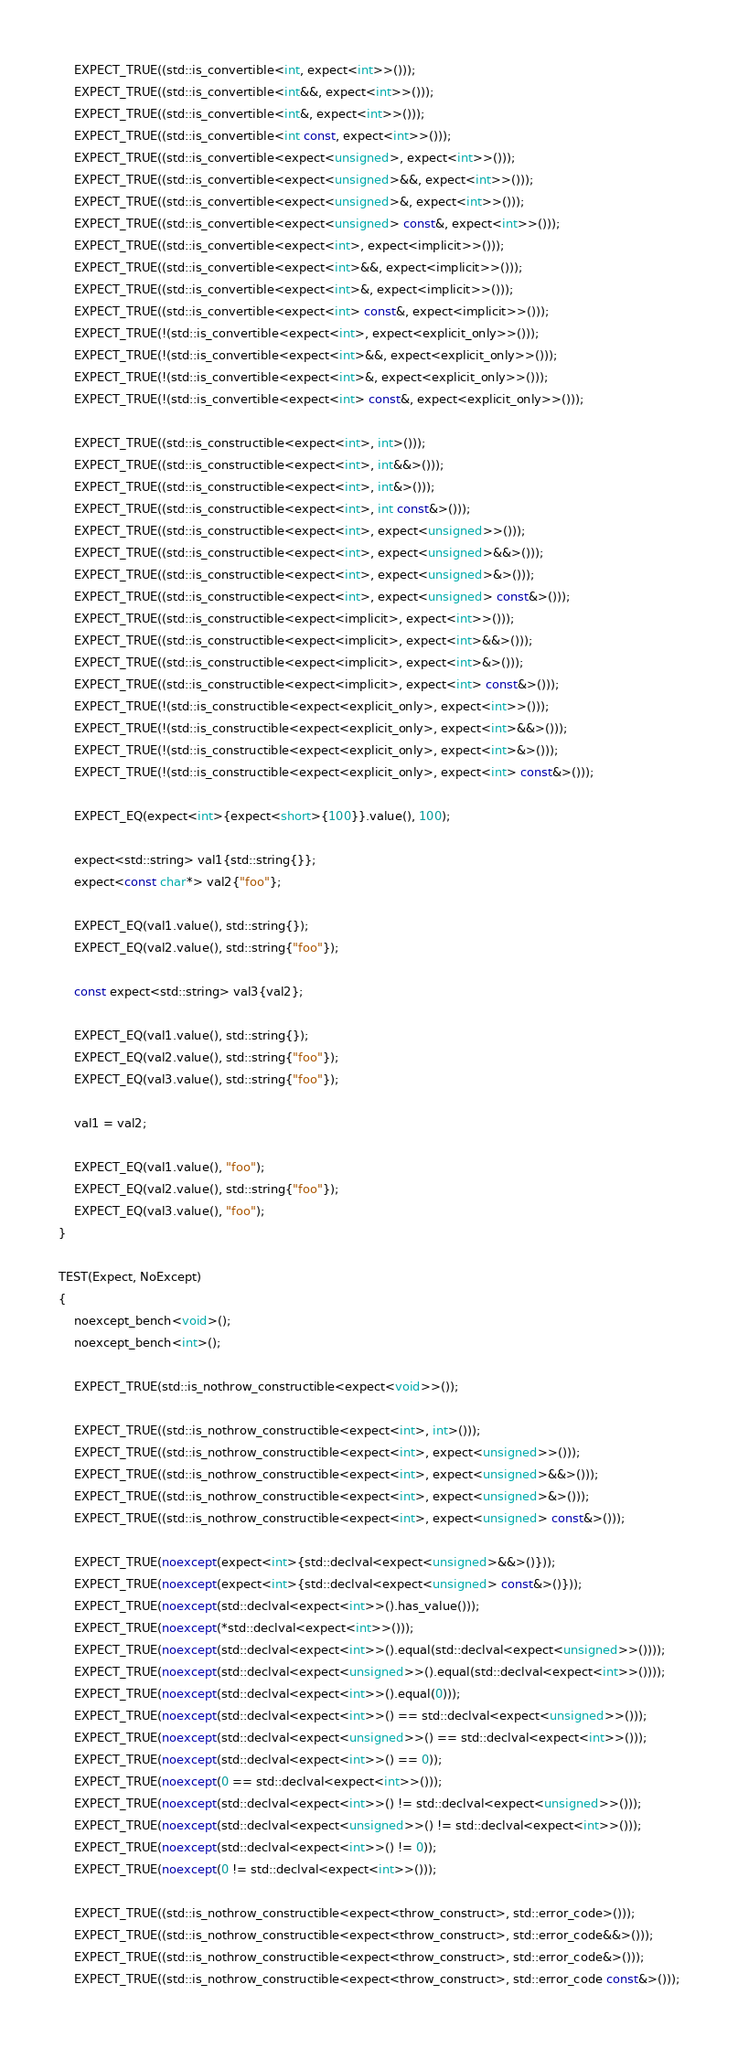Convert code to text. <code><loc_0><loc_0><loc_500><loc_500><_C++_>
    EXPECT_TRUE((std::is_convertible<int, expect<int>>()));
    EXPECT_TRUE((std::is_convertible<int&&, expect<int>>()));
    EXPECT_TRUE((std::is_convertible<int&, expect<int>>()));
    EXPECT_TRUE((std::is_convertible<int const, expect<int>>()));
    EXPECT_TRUE((std::is_convertible<expect<unsigned>, expect<int>>()));
    EXPECT_TRUE((std::is_convertible<expect<unsigned>&&, expect<int>>()));
    EXPECT_TRUE((std::is_convertible<expect<unsigned>&, expect<int>>()));
    EXPECT_TRUE((std::is_convertible<expect<unsigned> const&, expect<int>>()));
    EXPECT_TRUE((std::is_convertible<expect<int>, expect<implicit>>()));
    EXPECT_TRUE((std::is_convertible<expect<int>&&, expect<implicit>>()));
    EXPECT_TRUE((std::is_convertible<expect<int>&, expect<implicit>>()));
    EXPECT_TRUE((std::is_convertible<expect<int> const&, expect<implicit>>()));
    EXPECT_TRUE(!(std::is_convertible<expect<int>, expect<explicit_only>>()));
    EXPECT_TRUE(!(std::is_convertible<expect<int>&&, expect<explicit_only>>()));
    EXPECT_TRUE(!(std::is_convertible<expect<int>&, expect<explicit_only>>()));
    EXPECT_TRUE(!(std::is_convertible<expect<int> const&, expect<explicit_only>>()));

    EXPECT_TRUE((std::is_constructible<expect<int>, int>()));
    EXPECT_TRUE((std::is_constructible<expect<int>, int&&>()));
    EXPECT_TRUE((std::is_constructible<expect<int>, int&>()));
    EXPECT_TRUE((std::is_constructible<expect<int>, int const&>()));
    EXPECT_TRUE((std::is_constructible<expect<int>, expect<unsigned>>()));
    EXPECT_TRUE((std::is_constructible<expect<int>, expect<unsigned>&&>()));
    EXPECT_TRUE((std::is_constructible<expect<int>, expect<unsigned>&>()));
    EXPECT_TRUE((std::is_constructible<expect<int>, expect<unsigned> const&>()));
    EXPECT_TRUE((std::is_constructible<expect<implicit>, expect<int>>()));
    EXPECT_TRUE((std::is_constructible<expect<implicit>, expect<int>&&>()));
    EXPECT_TRUE((std::is_constructible<expect<implicit>, expect<int>&>()));
    EXPECT_TRUE((std::is_constructible<expect<implicit>, expect<int> const&>()));
    EXPECT_TRUE(!(std::is_constructible<expect<explicit_only>, expect<int>>()));
    EXPECT_TRUE(!(std::is_constructible<expect<explicit_only>, expect<int>&&>()));
    EXPECT_TRUE(!(std::is_constructible<expect<explicit_only>, expect<int>&>()));
    EXPECT_TRUE(!(std::is_constructible<expect<explicit_only>, expect<int> const&>()));

    EXPECT_EQ(expect<int>{expect<short>{100}}.value(), 100);

    expect<std::string> val1{std::string{}};
    expect<const char*> val2{"foo"};

    EXPECT_EQ(val1.value(), std::string{});
    EXPECT_EQ(val2.value(), std::string{"foo"});

    const expect<std::string> val3{val2};

    EXPECT_EQ(val1.value(), std::string{});
    EXPECT_EQ(val2.value(), std::string{"foo"});
    EXPECT_EQ(val3.value(), std::string{"foo"});

    val1 = val2;

    EXPECT_EQ(val1.value(), "foo");
    EXPECT_EQ(val2.value(), std::string{"foo"});
    EXPECT_EQ(val3.value(), "foo");
}

TEST(Expect, NoExcept)
{
    noexcept_bench<void>();
    noexcept_bench<int>();

    EXPECT_TRUE(std::is_nothrow_constructible<expect<void>>());

    EXPECT_TRUE((std::is_nothrow_constructible<expect<int>, int>()));
    EXPECT_TRUE((std::is_nothrow_constructible<expect<int>, expect<unsigned>>()));
    EXPECT_TRUE((std::is_nothrow_constructible<expect<int>, expect<unsigned>&&>()));
    EXPECT_TRUE((std::is_nothrow_constructible<expect<int>, expect<unsigned>&>()));
    EXPECT_TRUE((std::is_nothrow_constructible<expect<int>, expect<unsigned> const&>()));

    EXPECT_TRUE(noexcept(expect<int>{std::declval<expect<unsigned>&&>()}));
    EXPECT_TRUE(noexcept(expect<int>{std::declval<expect<unsigned> const&>()}));
    EXPECT_TRUE(noexcept(std::declval<expect<int>>().has_value()));
    EXPECT_TRUE(noexcept(*std::declval<expect<int>>()));
    EXPECT_TRUE(noexcept(std::declval<expect<int>>().equal(std::declval<expect<unsigned>>())));
    EXPECT_TRUE(noexcept(std::declval<expect<unsigned>>().equal(std::declval<expect<int>>())));
    EXPECT_TRUE(noexcept(std::declval<expect<int>>().equal(0)));
    EXPECT_TRUE(noexcept(std::declval<expect<int>>() == std::declval<expect<unsigned>>()));
    EXPECT_TRUE(noexcept(std::declval<expect<unsigned>>() == std::declval<expect<int>>()));
    EXPECT_TRUE(noexcept(std::declval<expect<int>>() == 0));
    EXPECT_TRUE(noexcept(0 == std::declval<expect<int>>()));
    EXPECT_TRUE(noexcept(std::declval<expect<int>>() != std::declval<expect<unsigned>>()));
    EXPECT_TRUE(noexcept(std::declval<expect<unsigned>>() != std::declval<expect<int>>()));
    EXPECT_TRUE(noexcept(std::declval<expect<int>>() != 0));
    EXPECT_TRUE(noexcept(0 != std::declval<expect<int>>()));

    EXPECT_TRUE((std::is_nothrow_constructible<expect<throw_construct>, std::error_code>()));
    EXPECT_TRUE((std::is_nothrow_constructible<expect<throw_construct>, std::error_code&&>()));
    EXPECT_TRUE((std::is_nothrow_constructible<expect<throw_construct>, std::error_code&>()));
    EXPECT_TRUE((std::is_nothrow_constructible<expect<throw_construct>, std::error_code const&>()));</code> 